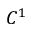<formula> <loc_0><loc_0><loc_500><loc_500>C ^ { 1 }</formula> 